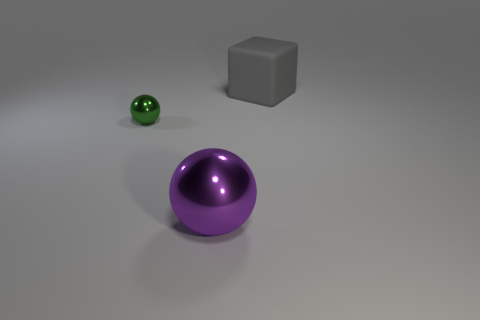Add 3 spheres. How many objects exist? 6 Subtract all spheres. How many objects are left? 1 Add 2 tiny red matte cubes. How many tiny red matte cubes exist? 2 Subtract 0 gray cylinders. How many objects are left? 3 Subtract all tiny blue matte balls. Subtract all metallic objects. How many objects are left? 1 Add 3 big purple metallic things. How many big purple metallic things are left? 4 